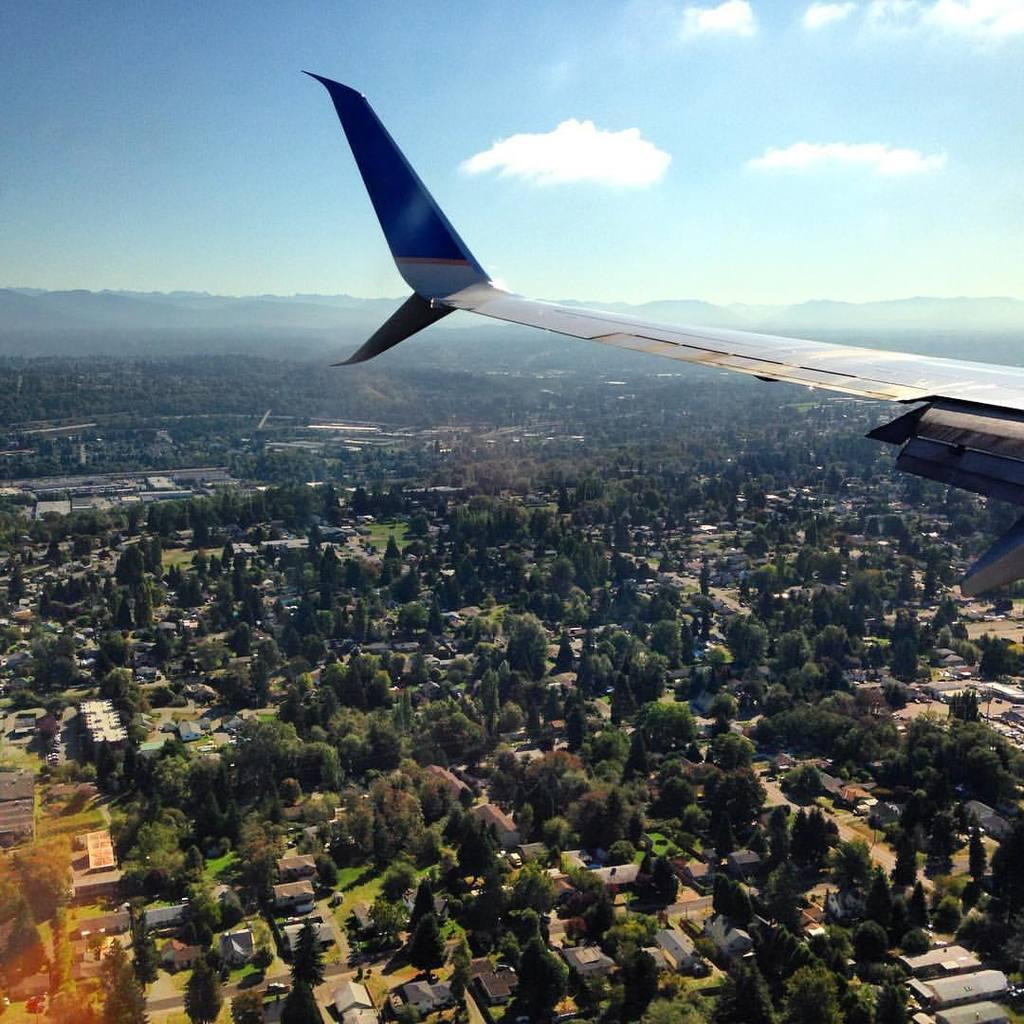What is located on the right side of the image? There is a part of an airplane on the right side of the image. What can be seen at the bottom of the image? There are many trees and buildings at the bottom of the image. What is visible at the top of the image? The sky is visible at the top of the image. What can be observed in the sky? Clouds are present in the sky. Reasoning: Let's think step by step in the main subjects and objects in the image based on the provided facts. We then formulate questions that focus on the location and characteristics of these subjects and objects, ensuring that each question can be answered definitively with the information given. We avoid yes/no questions and ensure that the language is simple and clear. Absurd Question/Answer: What type of attraction can be seen in the image? There is no attraction present in the image; it features a part of an airplane, trees, buildings, and a sky with clouds. What color is the yarn used to create the trees in the image? There is no yarn present in the image; the trees are depicted using a different artistic technique or medium. How does the yarn used to create the trees in the image affect the airplane's flight path? There is no yarn present in the image, and the airplane's flight path is not affected by any yarn. 